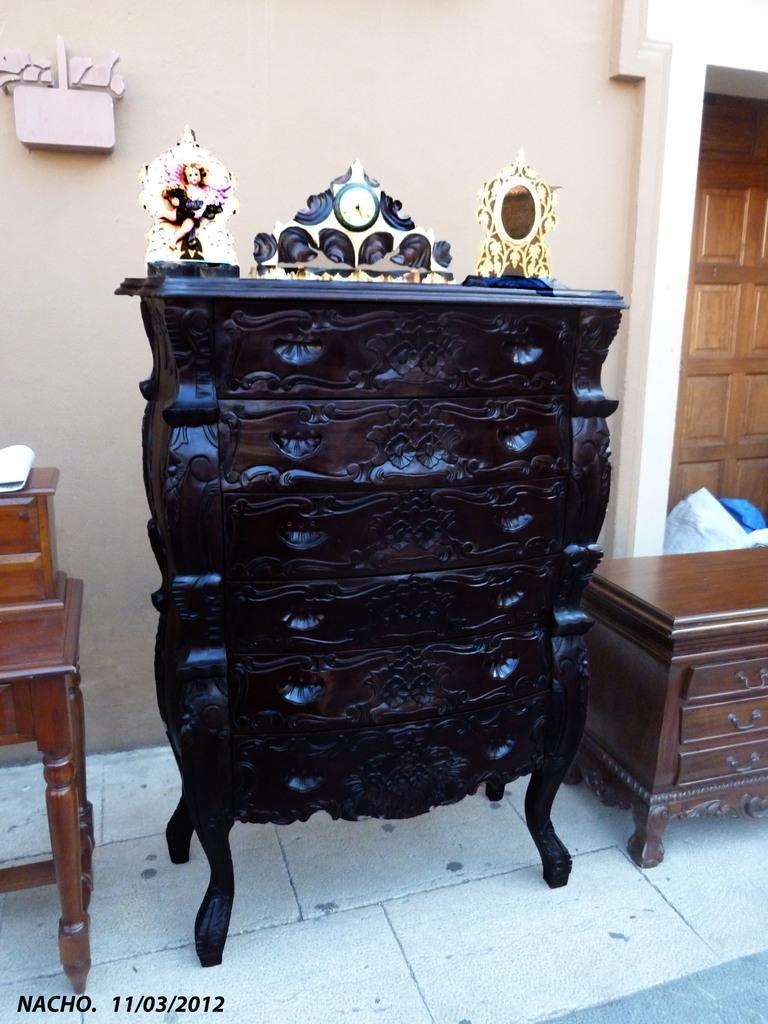Can you describe this image briefly? We can see furniture,table on the floor,behind this furniture we can see wall,door,cover. 